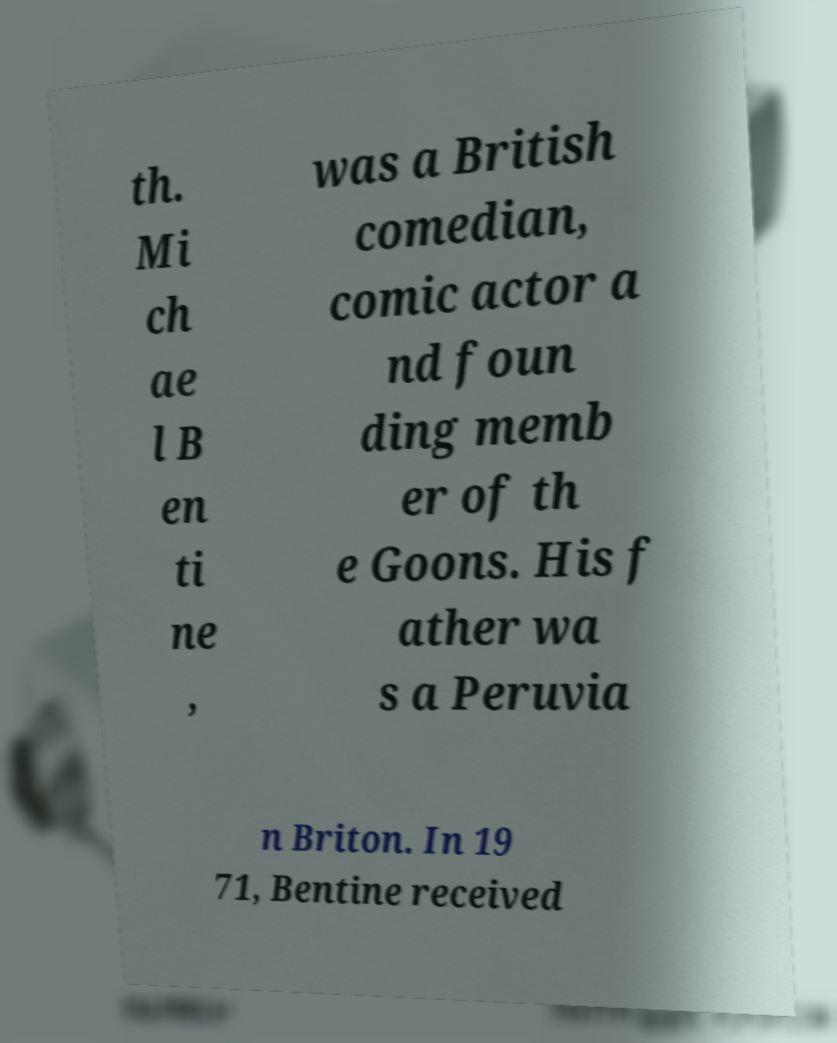Please identify and transcribe the text found in this image. th. Mi ch ae l B en ti ne , was a British comedian, comic actor a nd foun ding memb er of th e Goons. His f ather wa s a Peruvia n Briton. In 19 71, Bentine received 